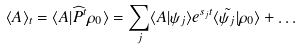<formula> <loc_0><loc_0><loc_500><loc_500>\langle A \rangle _ { t } = \langle A | \widehat { P } ^ { t } \rho _ { 0 } \rangle = \sum _ { j } \langle A | \psi _ { j } \rangle e ^ { s _ { j } t } \langle \tilde { \psi _ { j } } | \rho _ { 0 } \rangle + \dots</formula> 